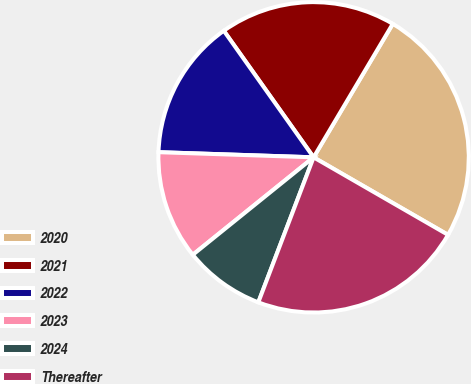Convert chart. <chart><loc_0><loc_0><loc_500><loc_500><pie_chart><fcel>2020<fcel>2021<fcel>2022<fcel>2023<fcel>2024<fcel>Thereafter<nl><fcel>24.8%<fcel>18.34%<fcel>14.65%<fcel>11.33%<fcel>8.4%<fcel>22.47%<nl></chart> 